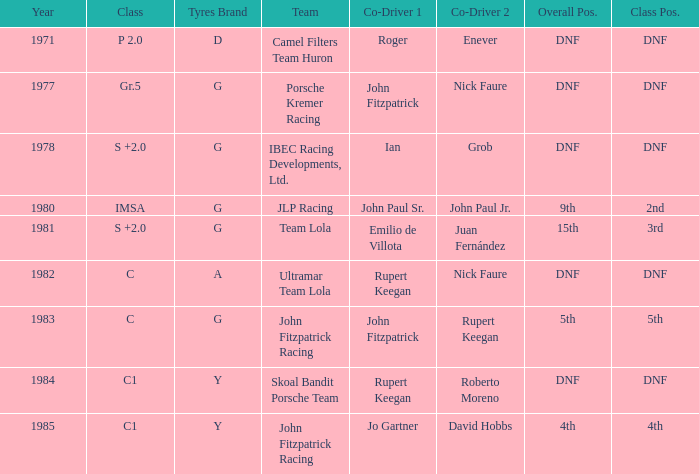Which tires were in Class C in years before 1983? A. 